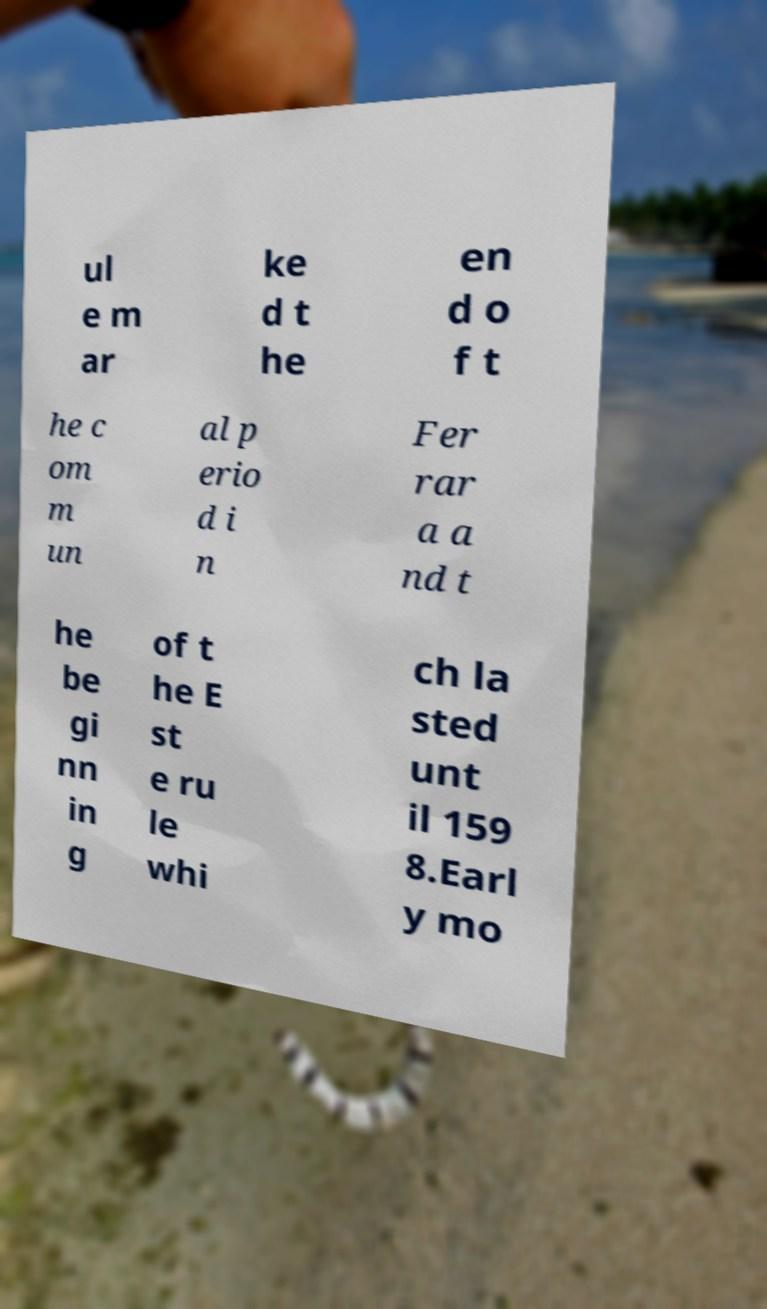I need the written content from this picture converted into text. Can you do that? ul e m ar ke d t he en d o f t he c om m un al p erio d i n Fer rar a a nd t he be gi nn in g of t he E st e ru le whi ch la sted unt il 159 8.Earl y mo 